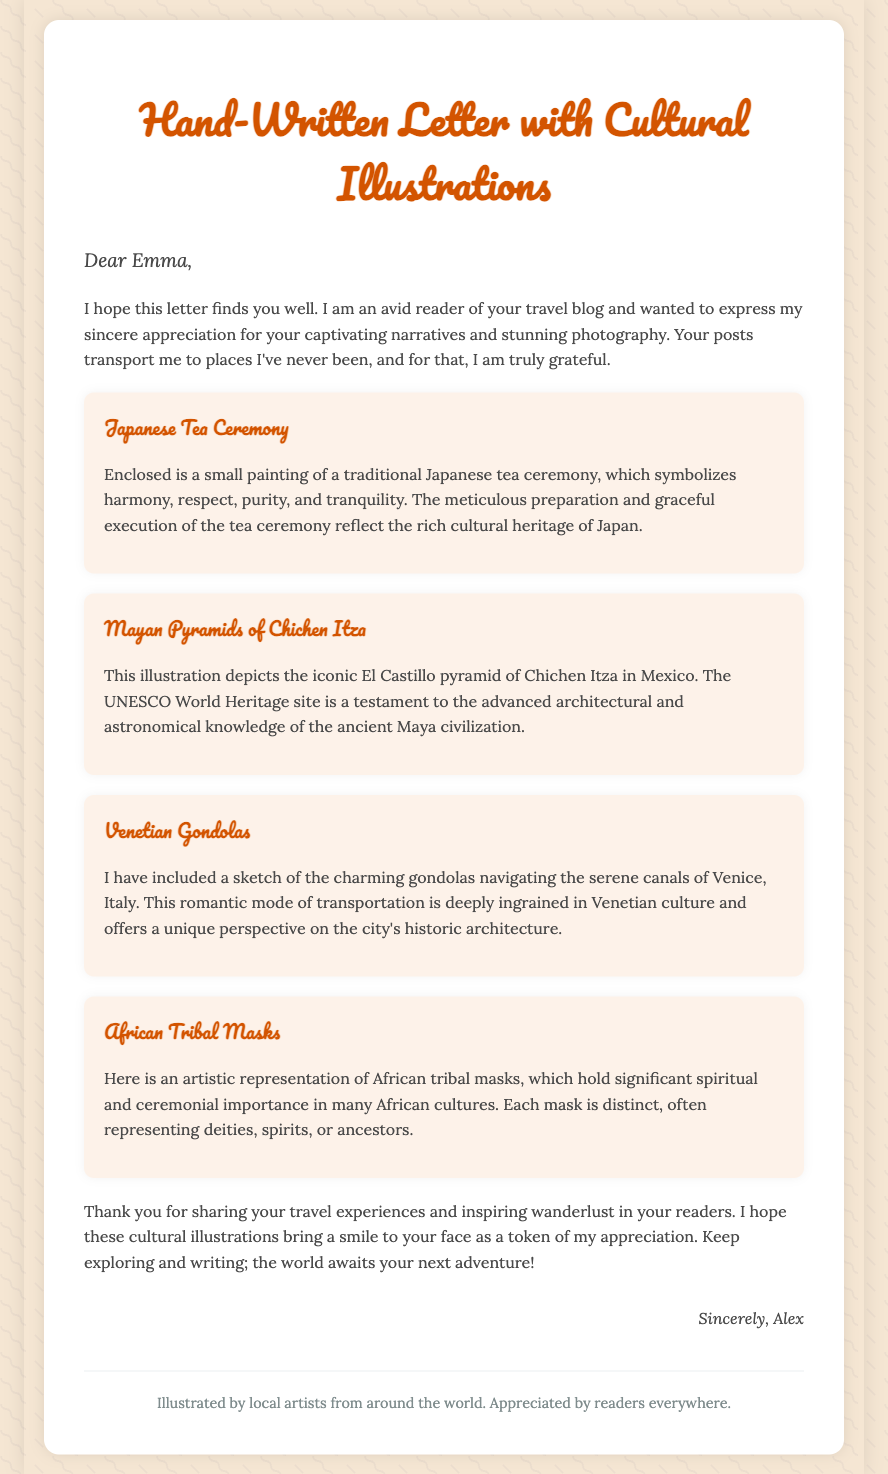what is the title of the document? The title of the document is prominently displayed at the top of the letter, indicating its theme and purpose.
Answer: Hand-Written Letter with Cultural Illustrations who is the recipient of the letter? The recipient's name is indicated at the beginning of the letter as an address to them.
Answer: Emma how many cultural illustrations are included in the letter? The document lists multiple illustrations, and each is categorized under a specific title, which indicates the number of illustrations.
Answer: Four what is depicted in the illustration related to Japan? The content of the illustration specifically mentions Japanese culture and practices, giving context about what it portrays.
Answer: Japanese Tea Ceremony what does the sketch of the Venetian Gondolas represent? The description refers to the significance of the mode of transport in its cultural context.
Answer: Romantic mode of transportation who signed the letter? The closing of the letter indicates the person who is writing and expressing appreciation to the recipient.
Answer: Alex 